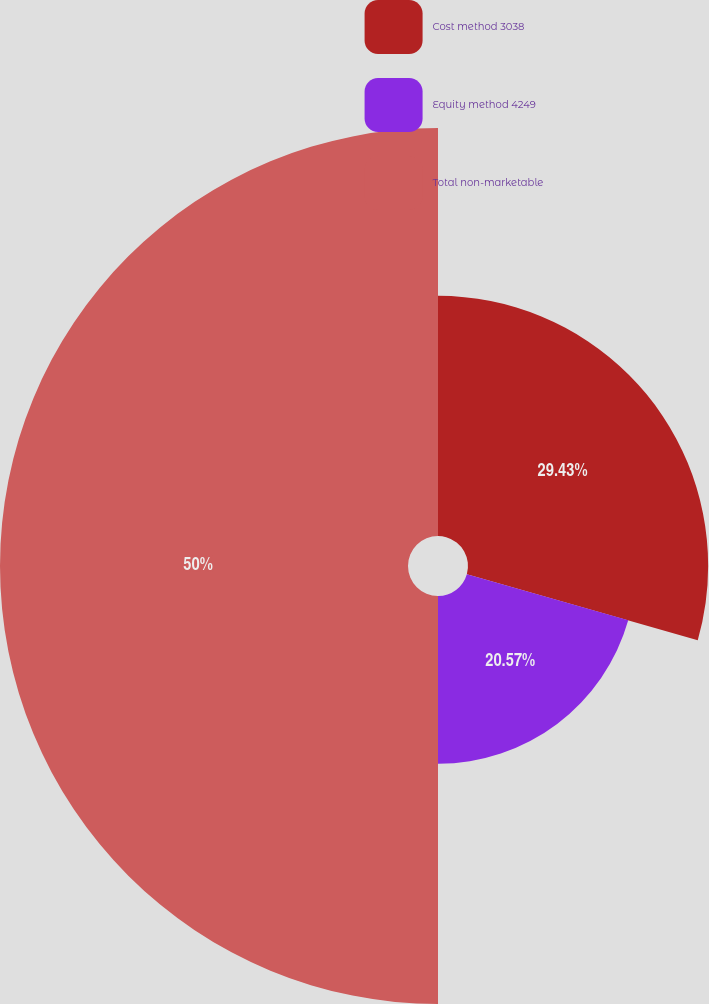<chart> <loc_0><loc_0><loc_500><loc_500><pie_chart><fcel>Cost method 3038<fcel>Equity method 4249<fcel>Total non-marketable<nl><fcel>29.43%<fcel>20.57%<fcel>50.0%<nl></chart> 